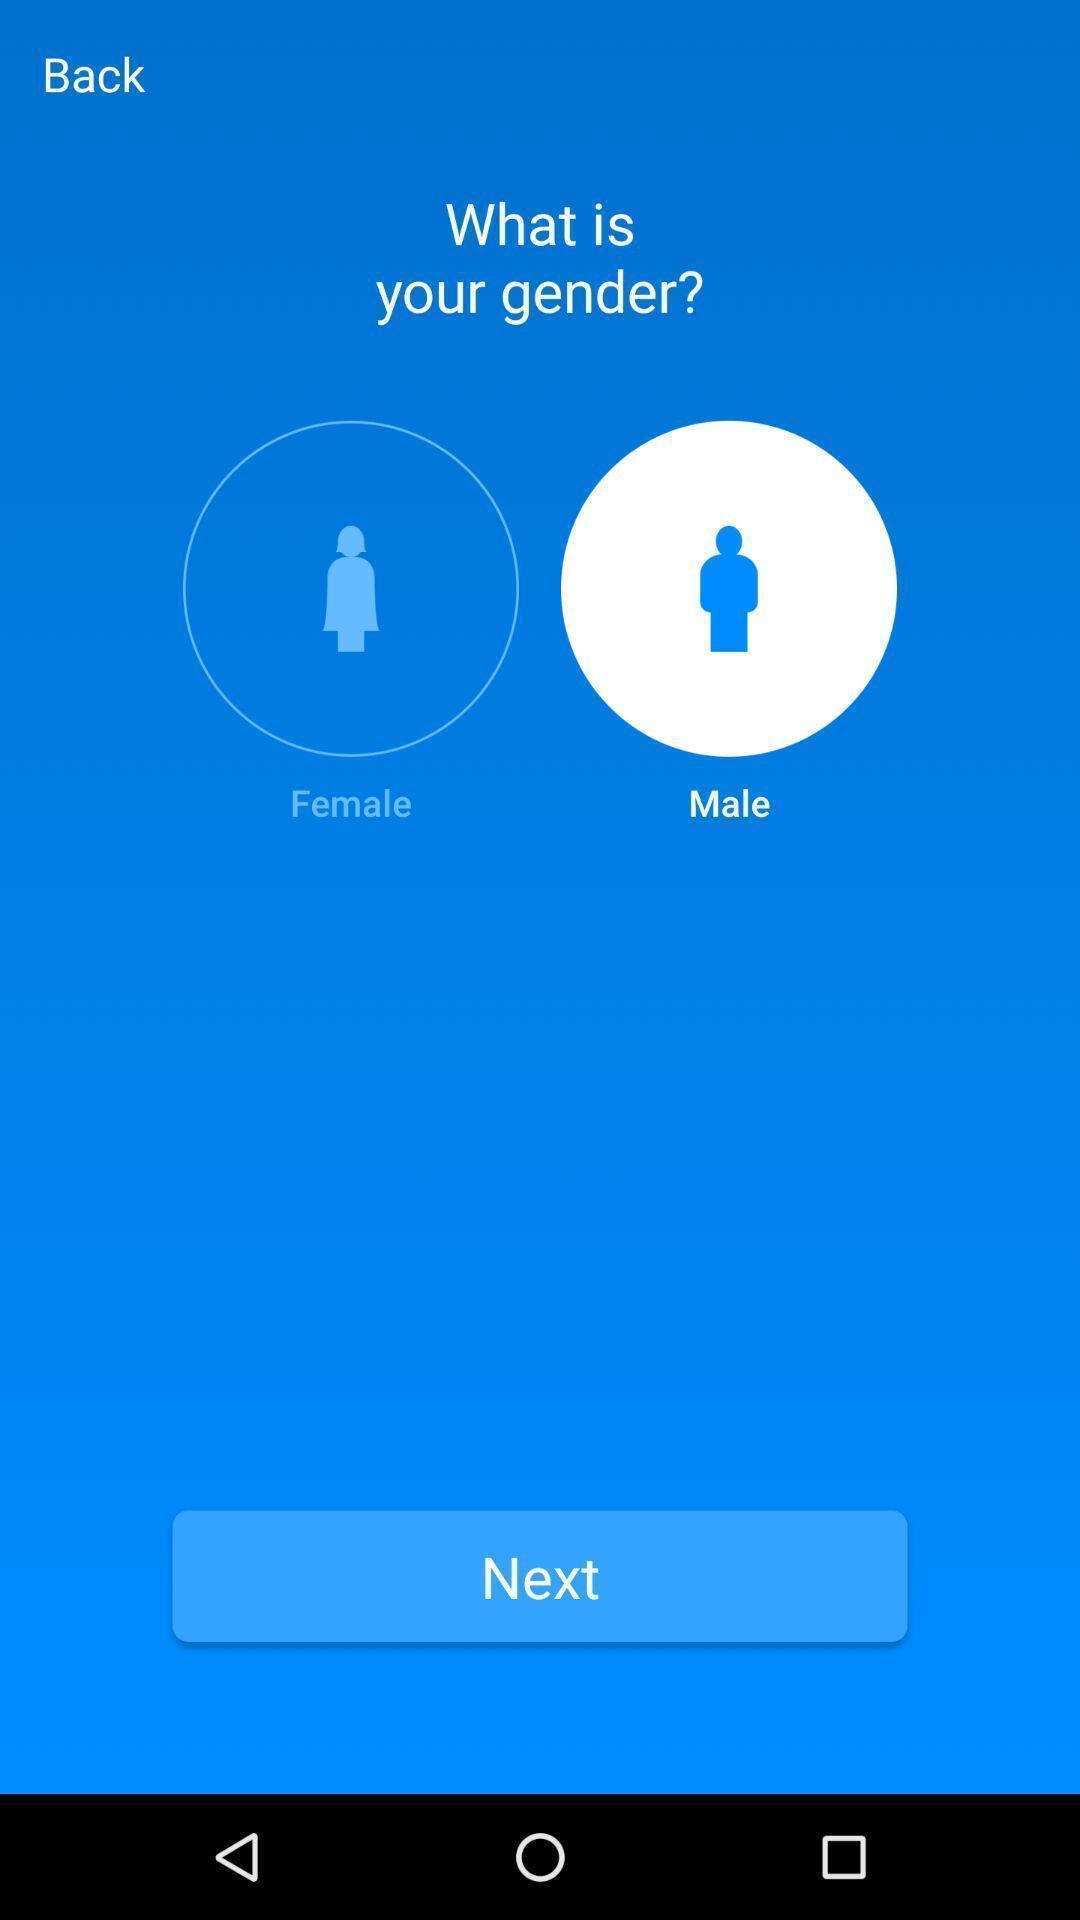Tell me about the visual elements in this screen capture. Screen showing to select gender with next option. 